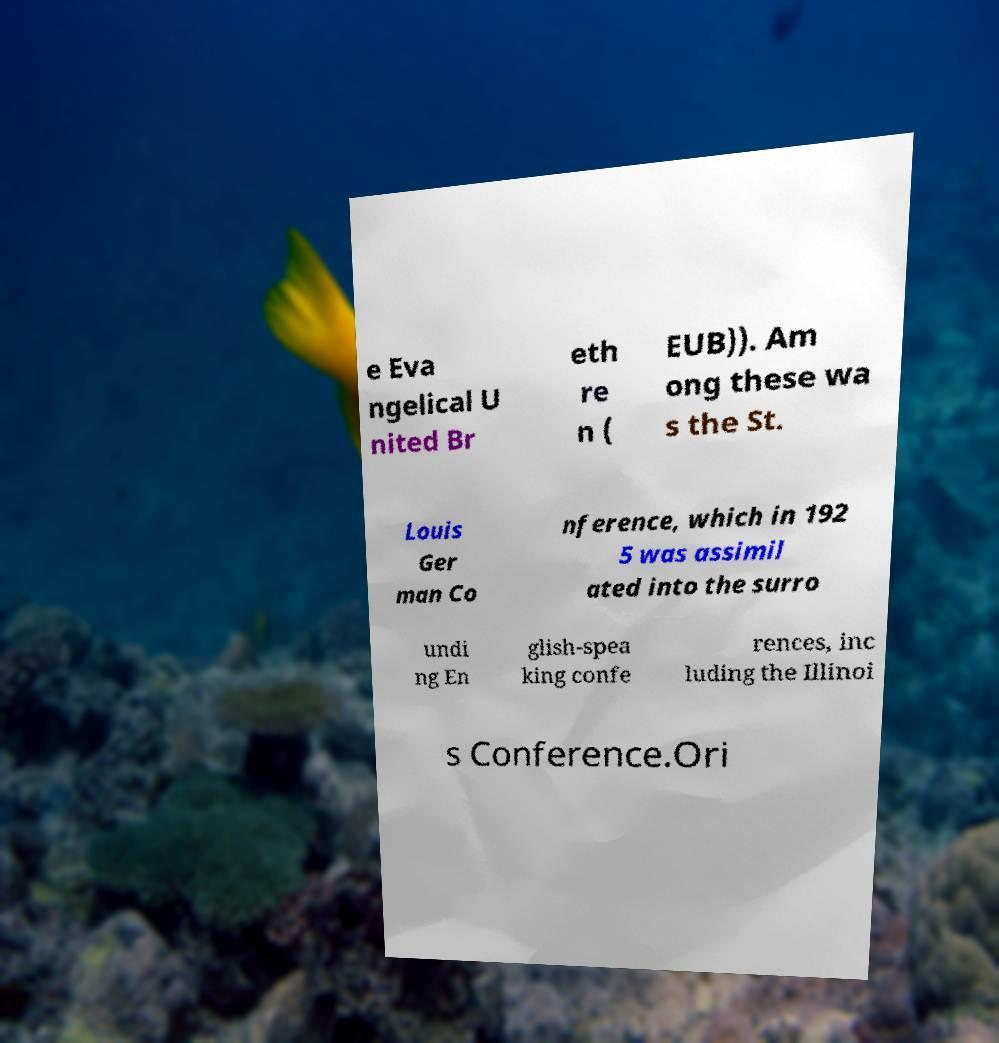I need the written content from this picture converted into text. Can you do that? e Eva ngelical U nited Br eth re n ( EUB)). Am ong these wa s the St. Louis Ger man Co nference, which in 192 5 was assimil ated into the surro undi ng En glish-spea king confe rences, inc luding the Illinoi s Conference.Ori 